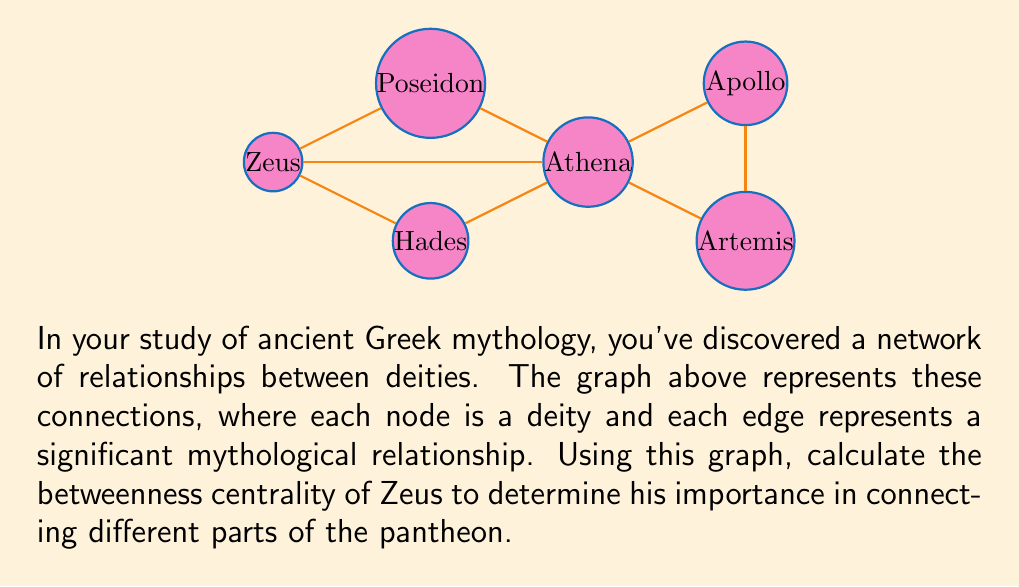Could you help me with this problem? To calculate the betweenness centrality of Zeus, we need to follow these steps:

1) First, let's recall the formula for betweenness centrality:

   $$C_B(v) = \sum_{s \neq v \neq t} \frac{\sigma_{st}(v)}{\sigma_{st}}$$

   where $\sigma_{st}$ is the total number of shortest paths from node $s$ to node $t$, and $\sigma_{st}(v)$ is the number of those paths that pass through $v$.

2) We need to consider all pairs of nodes (except those involving Zeus) and calculate the fraction of shortest paths between them that pass through Zeus.

3) Let's go through each pair:

   Poseidon - Hades: 1 path through Zeus out of 2 total paths
   Poseidon - Athena: 0 paths through Zeus out of 1 total path
   Poseidon - Apollo: 1 path through Zeus out of 2 total paths
   Poseidon - Artemis: 1 path through Zeus out of 2 total paths
   Hades - Athena: 0 paths through Zeus out of 1 total path
   Hades - Apollo: 1 path through Zeus out of 2 total paths
   Hades - Artemis: 1 path through Zeus out of 2 total paths
   Athena - Apollo: 0 paths through Zeus out of 1 total path
   Athena - Artemis: 0 paths through Zeus out of 1 total path
   Apollo - Artemis: 0 paths through Zeus out of 1 total path

4) Now, let's sum up the fractions:

   $$C_B(Zeus) = \frac{1}{2} + 0 + \frac{1}{2} + \frac{1}{2} + 0 + \frac{1}{2} + \frac{1}{2} + 0 + 0 + 0 = 2.5$$

5) In some cases, this raw score is normalized by dividing by the number of pairs of nodes not including the node in question. Here, that would be:

   $$\text{Number of pairs} = \frac{(n-1)(n-2)}{2} = \frac{(6-1)(6-2)}{2} = 10$$

6) So, the normalized betweenness centrality would be:

   $$C'_B(Zeus) = \frac{2.5}{10} = 0.25$$
Answer: $0.25$ 